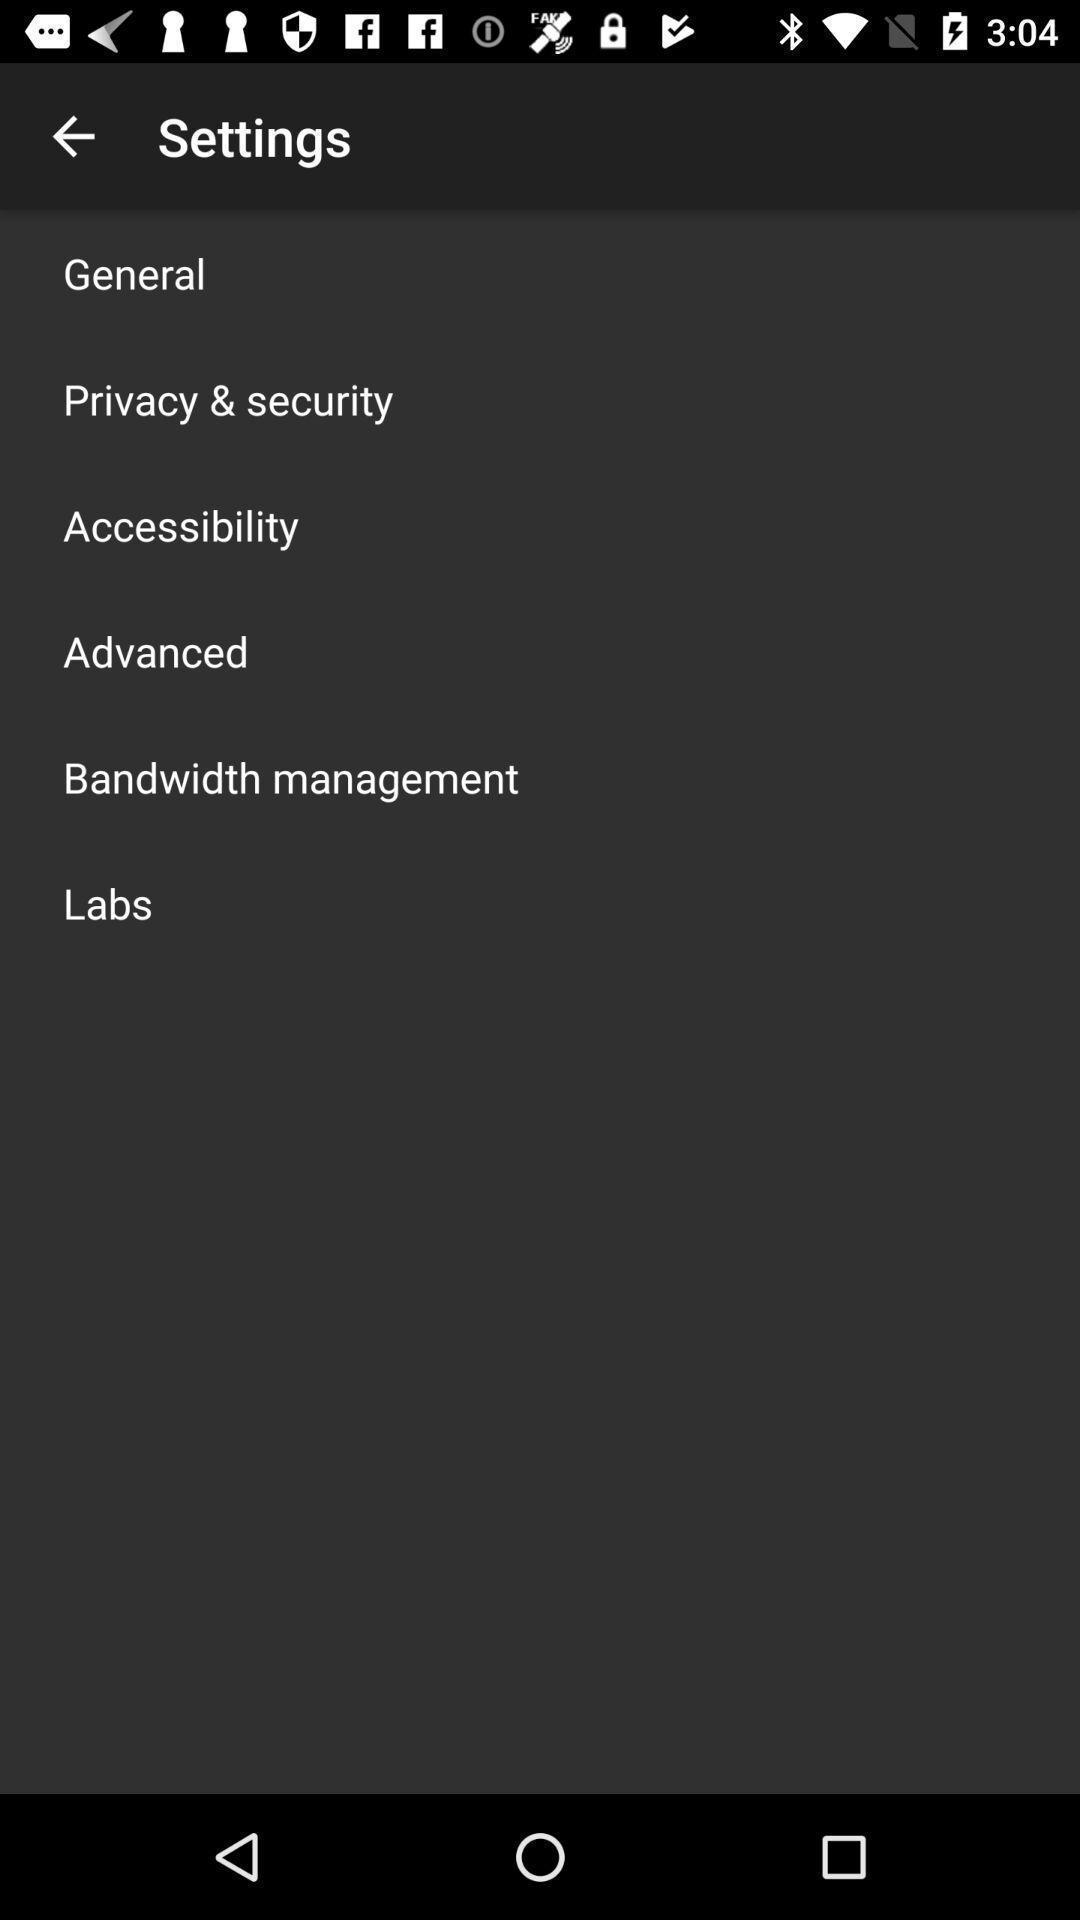Describe the visual elements of this screenshot. Page displays various settings in app. 